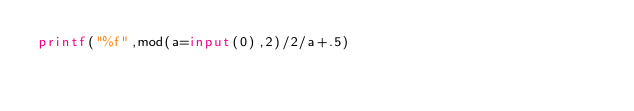Convert code to text. <code><loc_0><loc_0><loc_500><loc_500><_Octave_>printf("%f",mod(a=input(0),2)/2/a+.5)</code> 